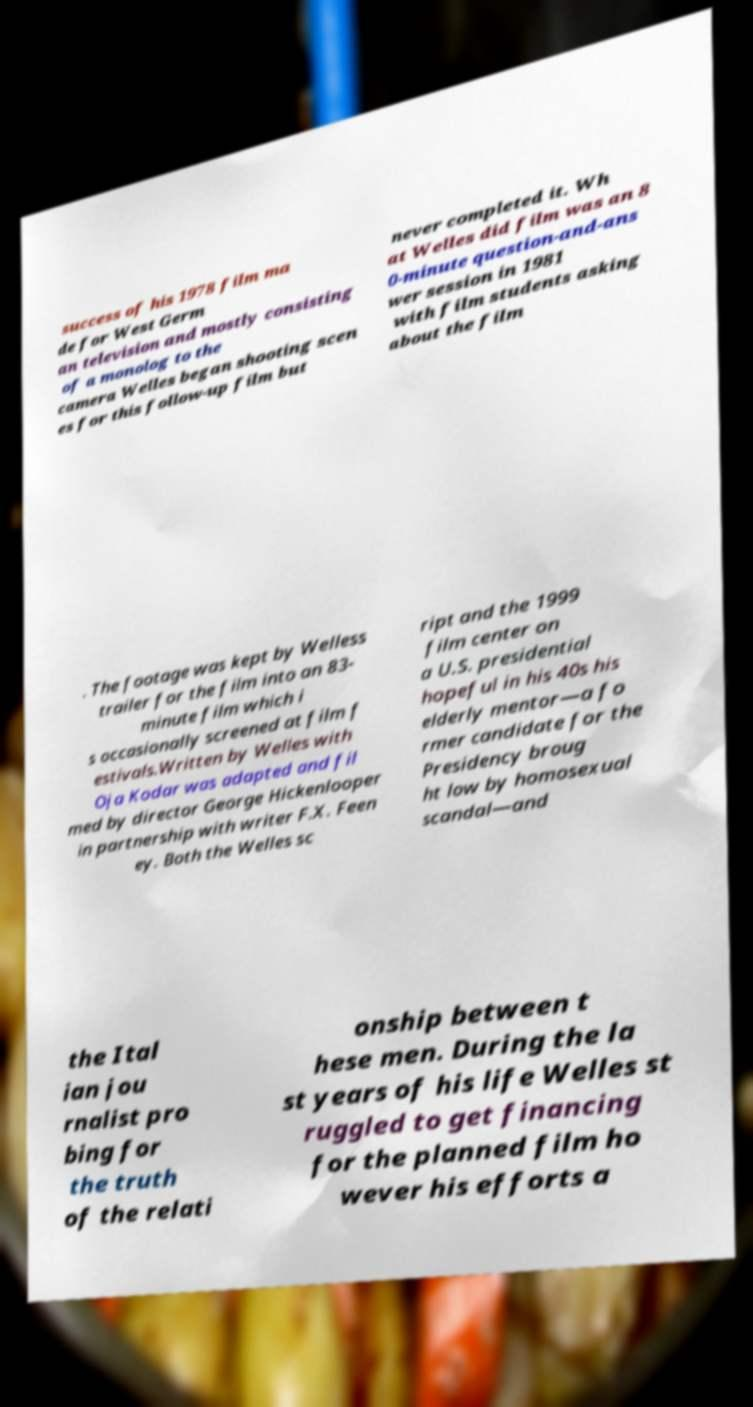I need the written content from this picture converted into text. Can you do that? success of his 1978 film ma de for West Germ an television and mostly consisting of a monolog to the camera Welles began shooting scen es for this follow-up film but never completed it. Wh at Welles did film was an 8 0-minute question-and-ans wer session in 1981 with film students asking about the film . The footage was kept by Welless trailer for the film into an 83- minute film which i s occasionally screened at film f estivals.Written by Welles with Oja Kodar was adapted and fil med by director George Hickenlooper in partnership with writer F.X. Feen ey. Both the Welles sc ript and the 1999 film center on a U.S. presidential hopeful in his 40s his elderly mentor—a fo rmer candidate for the Presidency broug ht low by homosexual scandal—and the Ital ian jou rnalist pro bing for the truth of the relati onship between t hese men. During the la st years of his life Welles st ruggled to get financing for the planned film ho wever his efforts a 